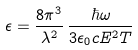<formula> <loc_0><loc_0><loc_500><loc_500>\epsilon = \frac { 8 \pi ^ { 3 } } { \lambda ^ { 2 } } \, \frac { \hbar { \omega } } { 3 \epsilon _ { 0 } c E ^ { 2 } T }</formula> 